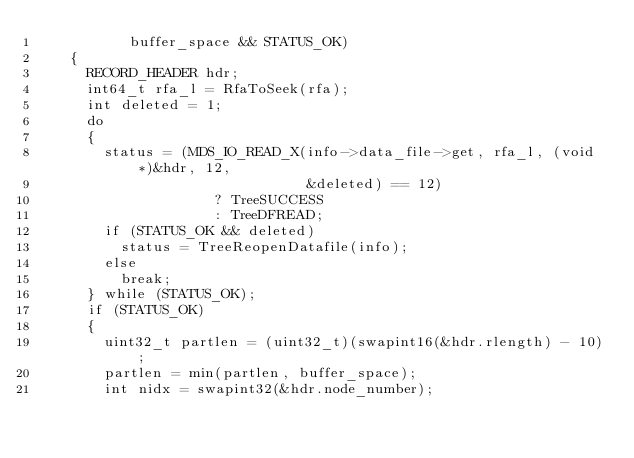<code> <loc_0><loc_0><loc_500><loc_500><_C_>           buffer_space && STATUS_OK)
    {
      RECORD_HEADER hdr;
      int64_t rfa_l = RfaToSeek(rfa);
      int deleted = 1;
      do
      {
        status = (MDS_IO_READ_X(info->data_file->get, rfa_l, (void *)&hdr, 12,
                                &deleted) == 12)
                     ? TreeSUCCESS
                     : TreeDFREAD;
        if (STATUS_OK && deleted)
          status = TreeReopenDatafile(info);
        else
          break;
      } while (STATUS_OK);
      if (STATUS_OK)
      {
        uint32_t partlen = (uint32_t)(swapint16(&hdr.rlength) - 10);
        partlen = min(partlen, buffer_space);
        int nidx = swapint32(&hdr.node_number);</code> 